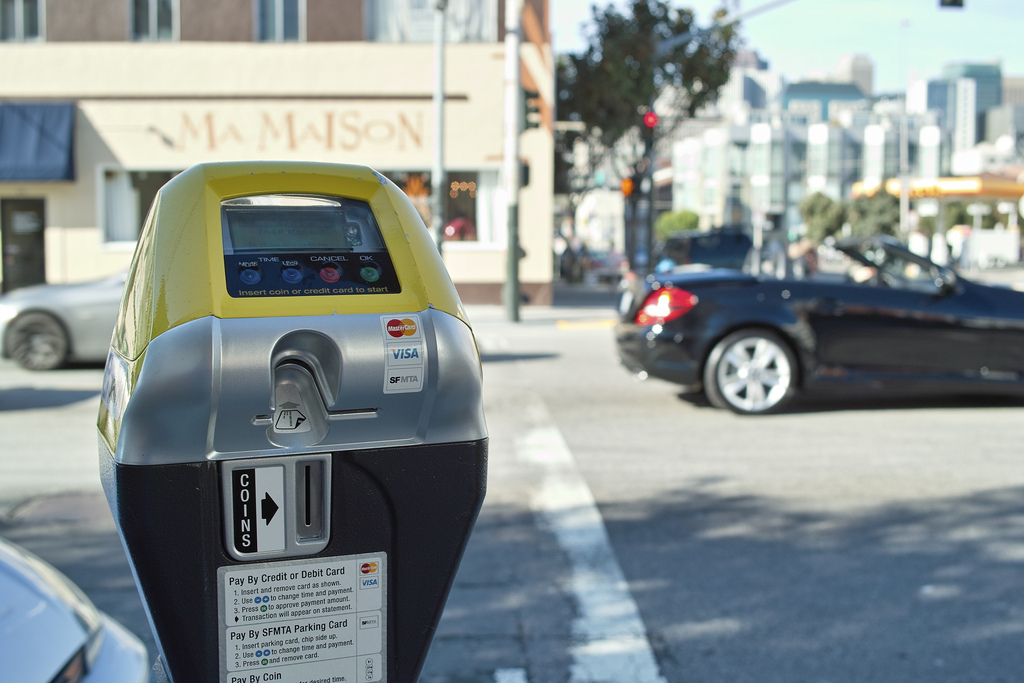Is the black vehicle on the left side? No, the black vehicle is not on the left side. 